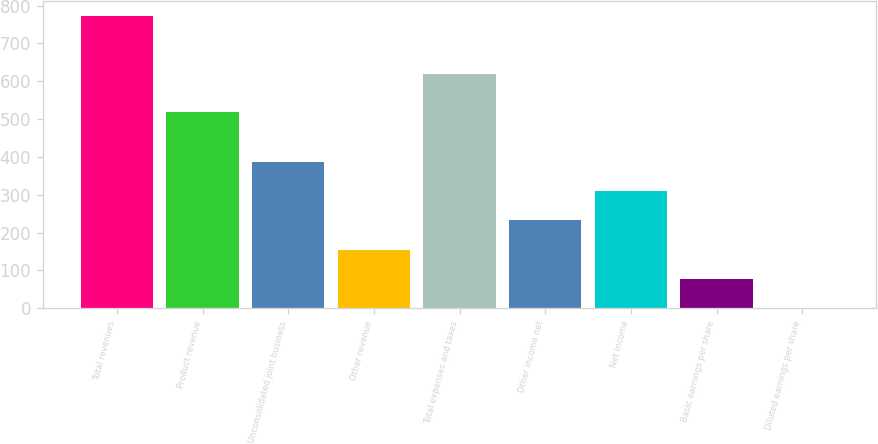Convert chart. <chart><loc_0><loc_0><loc_500><loc_500><bar_chart><fcel>Total revenues<fcel>Product revenue<fcel>Unconsolidated joint business<fcel>Other revenue<fcel>Total expenses and taxes<fcel>Other income net<fcel>Net income<fcel>Basic earnings per share<fcel>Diluted earnings per share<nl><fcel>773.2<fcel>518.6<fcel>386.89<fcel>155.08<fcel>618.6<fcel>232.35<fcel>309.62<fcel>77.81<fcel>0.54<nl></chart> 